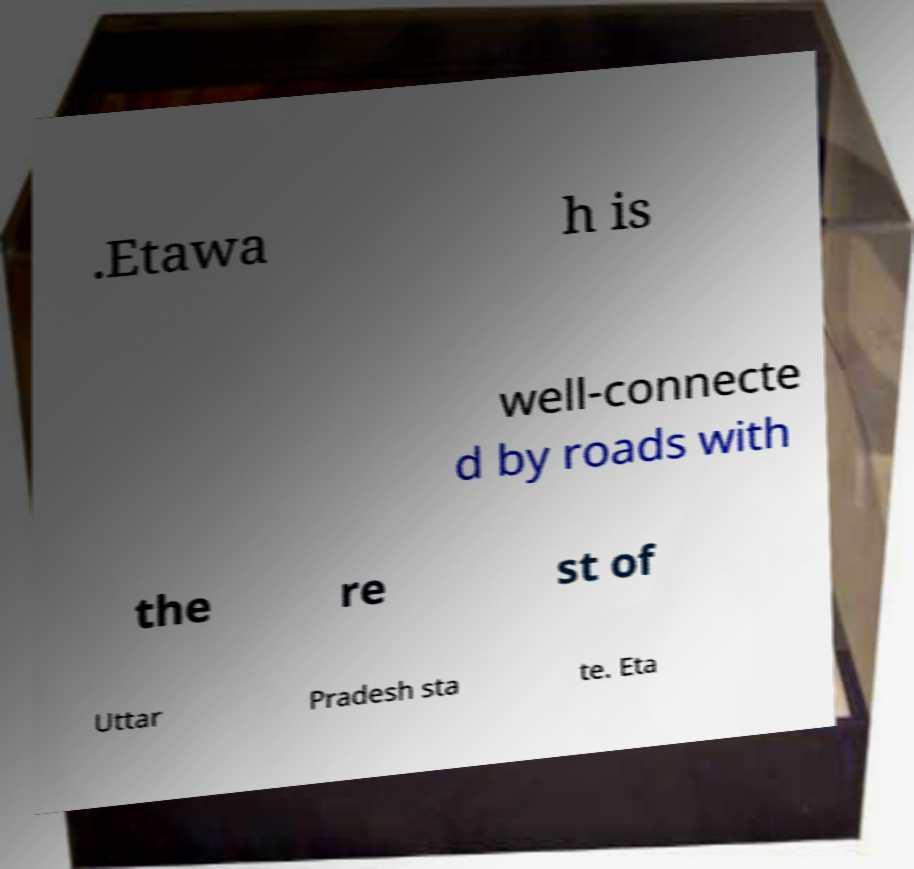I need the written content from this picture converted into text. Can you do that? .Etawa h is well-connecte d by roads with the re st of Uttar Pradesh sta te. Eta 